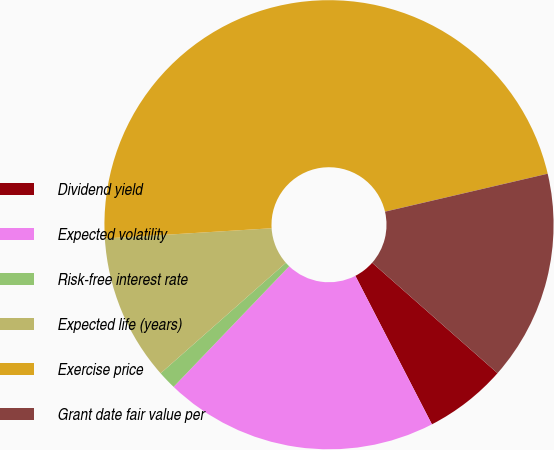Convert chart. <chart><loc_0><loc_0><loc_500><loc_500><pie_chart><fcel>Dividend yield<fcel>Expected volatility<fcel>Risk-free interest rate<fcel>Expected life (years)<fcel>Exercise price<fcel>Grant date fair value per<nl><fcel>5.93%<fcel>19.74%<fcel>1.33%<fcel>10.53%<fcel>47.33%<fcel>15.14%<nl></chart> 